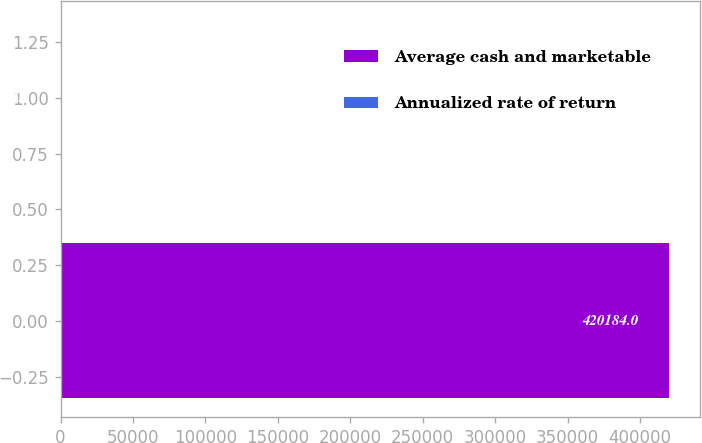Convert chart to OTSL. <chart><loc_0><loc_0><loc_500><loc_500><bar_chart><fcel>Average cash and marketable<fcel>Annualized rate of return<nl><fcel>420184<fcel>5.7<nl></chart> 